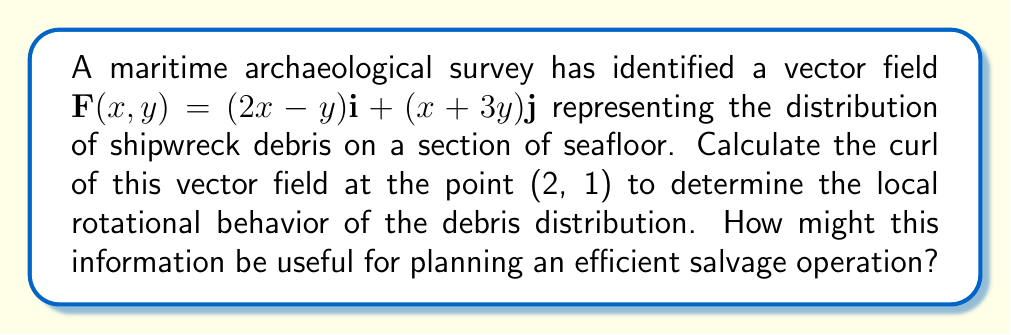What is the answer to this math problem? To solve this problem, we'll follow these steps:

1) The curl of a two-dimensional vector field $\mathbf{F}(x,y) = P(x,y)\mathbf{i} + Q(x,y)\mathbf{j}$ is given by:

   $$\text{curl } \mathbf{F} = \left(\frac{\partial Q}{\partial x} - \frac{\partial P}{\partial y}\right)\mathbf{k}$$

2) In our case, $P(x,y) = 2x-y$ and $Q(x,y) = x+3y$

3) Let's calculate the partial derivatives:
   
   $\frac{\partial Q}{\partial x} = \frac{\partial}{\partial x}(x+3y) = 1$
   
   $\frac{\partial P}{\partial y} = \frac{\partial}{\partial y}(2x-y) = -1$

4) Now we can calculate the curl:

   $$\text{curl } \mathbf{F} = (1 - (-1))\mathbf{k} = 2\mathbf{k}$$

5) This result is constant, meaning it's the same at all points, including (2, 1).

The non-zero curl indicates a rotational component in the debris distribution. This information can be useful for planning a salvage operation as it suggests that debris might be concentrated in circular patterns. Salvage teams could focus their efforts on these areas of rotation, potentially recovering more artifacts efficiently.
Answer: $2\mathbf{k}$ 